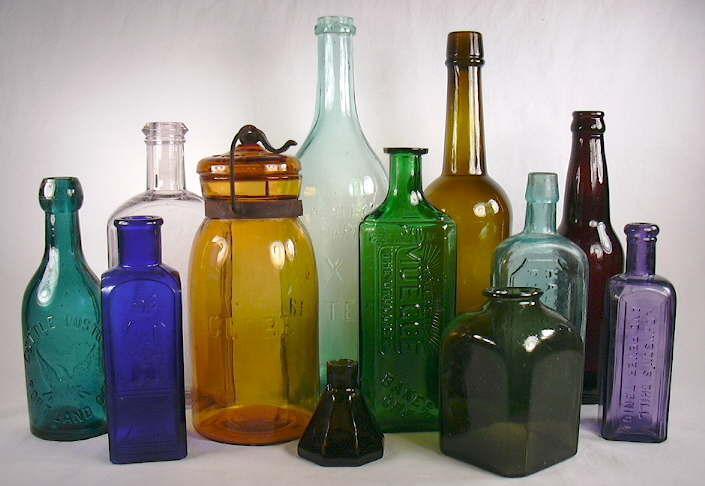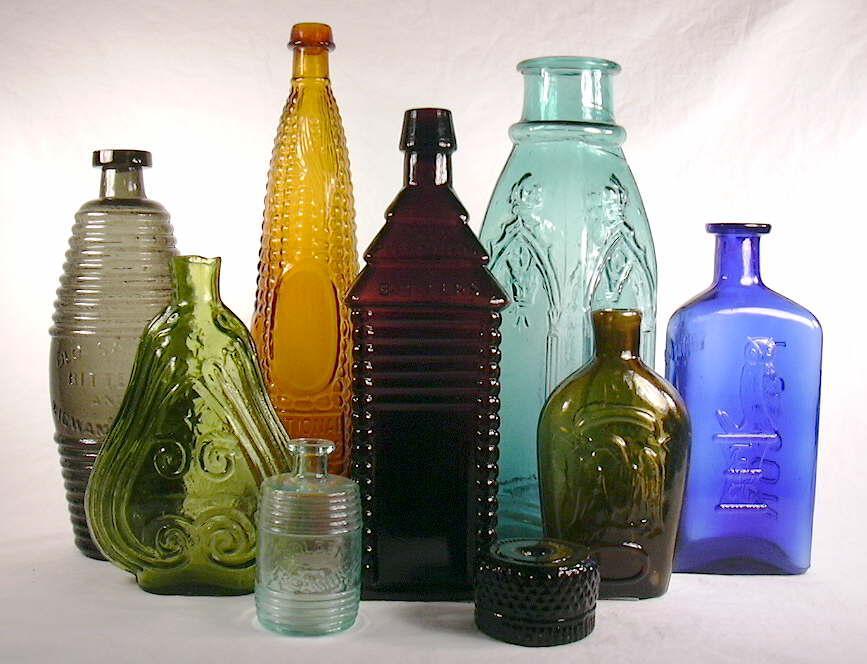The first image is the image on the left, the second image is the image on the right. Considering the images on both sides, is "One image features only upright bottles in a variety of shapes, sizes and colors, and includes at least one bottle with a paper label." valid? Answer yes or no. No. The first image is the image on the left, the second image is the image on the right. Examine the images to the left and right. Is the description "There is a blue bottle in both images." accurate? Answer yes or no. Yes. 